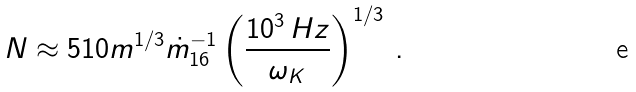<formula> <loc_0><loc_0><loc_500><loc_500>N \approx 5 1 0 m ^ { 1 / 3 } \dot { m } _ { 1 6 } ^ { - 1 } \left ( \frac { 1 0 ^ { 3 } \, H z } { \omega _ { K } } \right ) ^ { 1 / 3 } \, .</formula> 